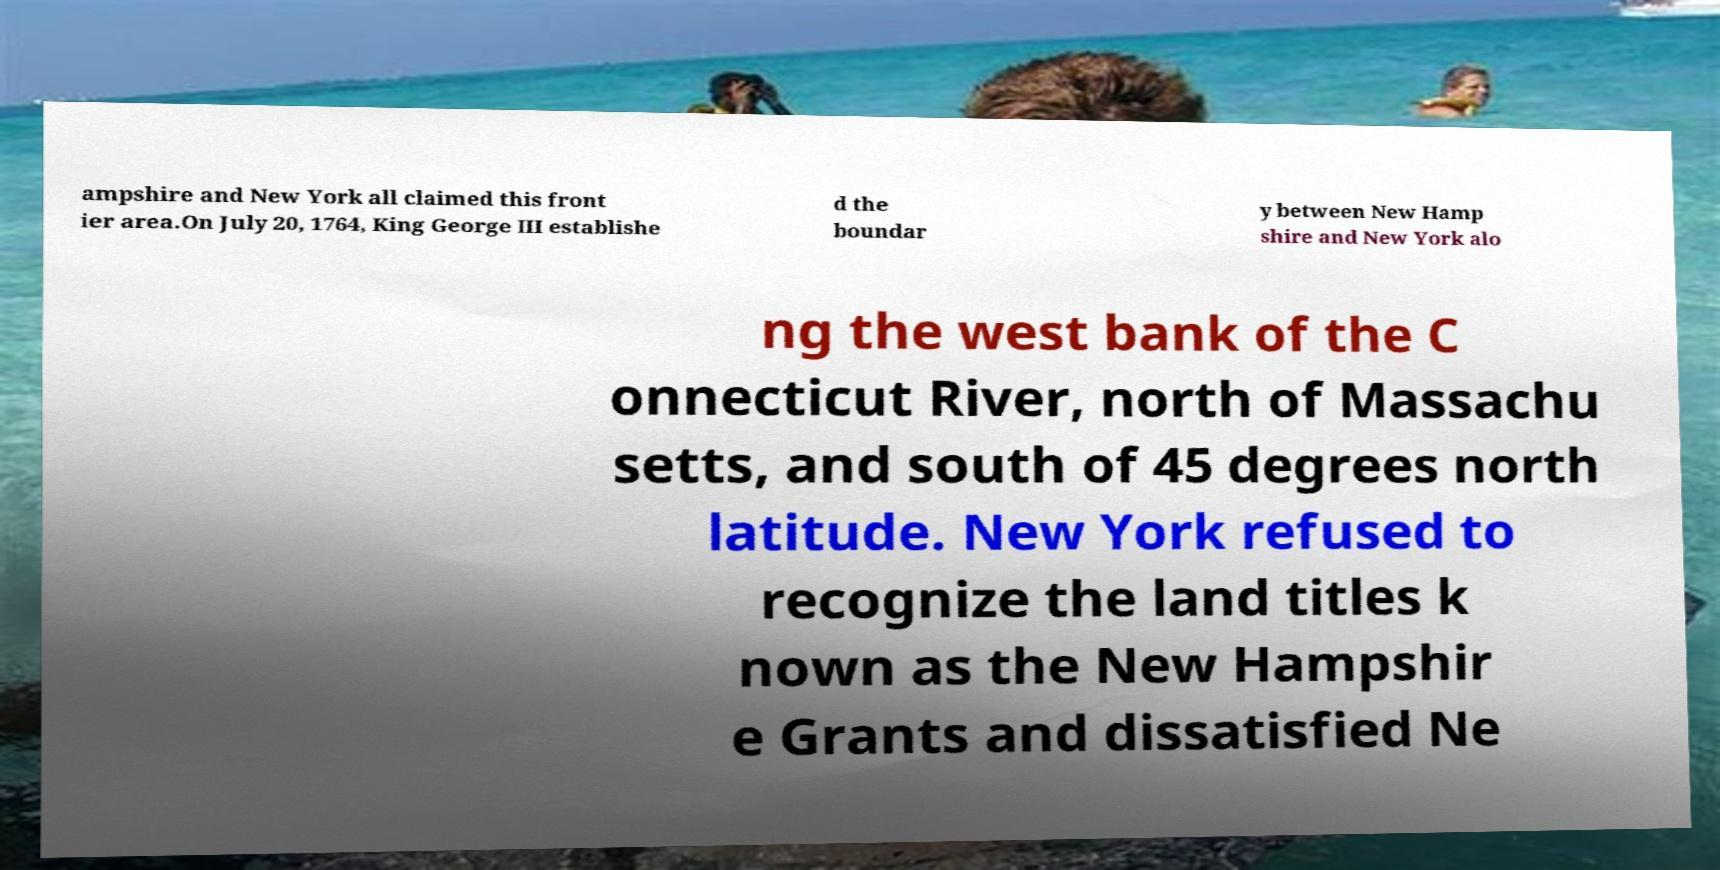Can you accurately transcribe the text from the provided image for me? ampshire and New York all claimed this front ier area.On July 20, 1764, King George III establishe d the boundar y between New Hamp shire and New York alo ng the west bank of the C onnecticut River, north of Massachu setts, and south of 45 degrees north latitude. New York refused to recognize the land titles k nown as the New Hampshir e Grants and dissatisfied Ne 